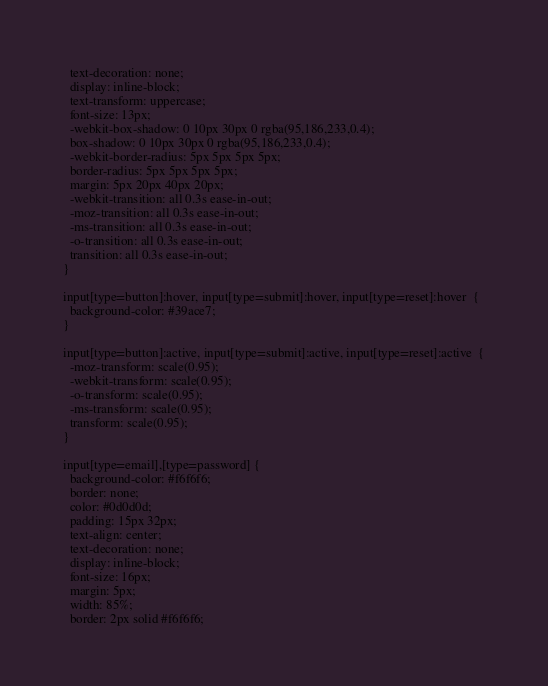Convert code to text. <code><loc_0><loc_0><loc_500><loc_500><_PHP_>  text-decoration: none;
  display: inline-block;
  text-transform: uppercase;
  font-size: 13px;
  -webkit-box-shadow: 0 10px 30px 0 rgba(95,186,233,0.4);
  box-shadow: 0 10px 30px 0 rgba(95,186,233,0.4);
  -webkit-border-radius: 5px 5px 5px 5px;
  border-radius: 5px 5px 5px 5px;
  margin: 5px 20px 40px 20px;
  -webkit-transition: all 0.3s ease-in-out;
  -moz-transition: all 0.3s ease-in-out;
  -ms-transition: all 0.3s ease-in-out;
  -o-transition: all 0.3s ease-in-out;
  transition: all 0.3s ease-in-out;
}

input[type=button]:hover, input[type=submit]:hover, input[type=reset]:hover  {
  background-color: #39ace7;
}

input[type=button]:active, input[type=submit]:active, input[type=reset]:active  {
  -moz-transform: scale(0.95);
  -webkit-transform: scale(0.95);
  -o-transform: scale(0.95);
  -ms-transform: scale(0.95);
  transform: scale(0.95);
}

input[type=email],[type=password] {
  background-color: #f6f6f6;
  border: none;
  color: #0d0d0d;
  padding: 15px 32px;
  text-align: center;
  text-decoration: none;
  display: inline-block;
  font-size: 16px;
  margin: 5px;
  width: 85%;
  border: 2px solid #f6f6f6;</code> 